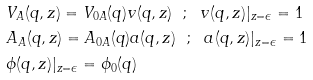Convert formula to latex. <formula><loc_0><loc_0><loc_500><loc_500>& V _ { A } ( q , z ) = V _ { 0 A } ( q ) v ( q , z ) \ \ ; \ \ v ( q , z ) | _ { z = \epsilon } = 1 \\ & A _ { A } ( q , z ) = A _ { 0 A } ( q ) a ( q , z ) \ \ ; \ \ a ( q , z ) | _ { z = \epsilon } = 1 \\ & \phi ( q , z ) | _ { z = \epsilon } = \phi _ { 0 } ( q )</formula> 